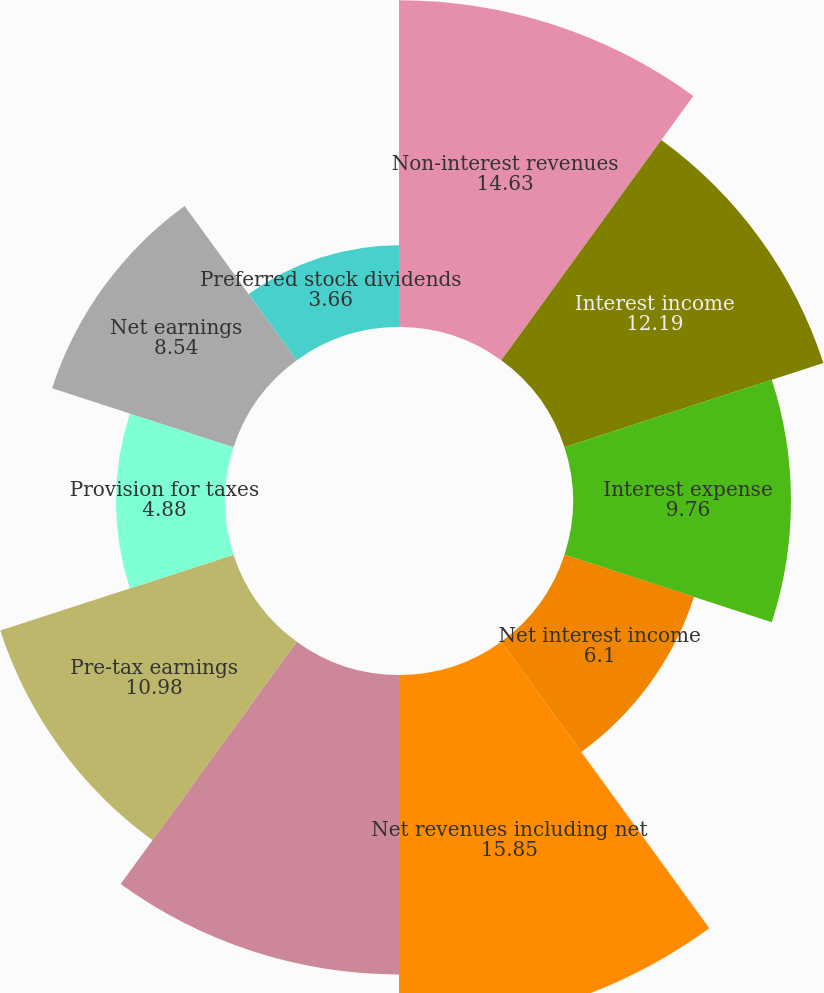Convert chart. <chart><loc_0><loc_0><loc_500><loc_500><pie_chart><fcel>Non-interest revenues<fcel>Interest income<fcel>Interest expense<fcel>Net interest income<fcel>Net revenues including net<fcel>Operating expenses 1<fcel>Pre-tax earnings<fcel>Provision for taxes<fcel>Net earnings<fcel>Preferred stock dividends<nl><fcel>14.63%<fcel>12.19%<fcel>9.76%<fcel>6.1%<fcel>15.85%<fcel>13.41%<fcel>10.98%<fcel>4.88%<fcel>8.54%<fcel>3.66%<nl></chart> 